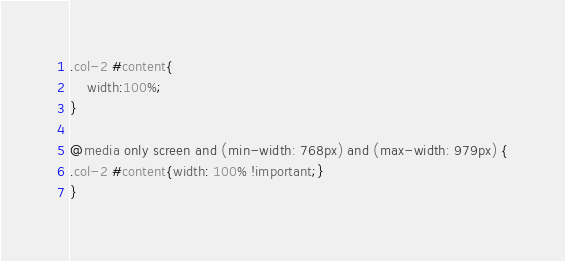Convert code to text. <code><loc_0><loc_0><loc_500><loc_500><_CSS_>.col-2 #content{
    width:100%;
}

@media only screen and (min-width: 768px) and (max-width: 979px) {
.col-2 #content{width: 100% !important;}
}
</code> 